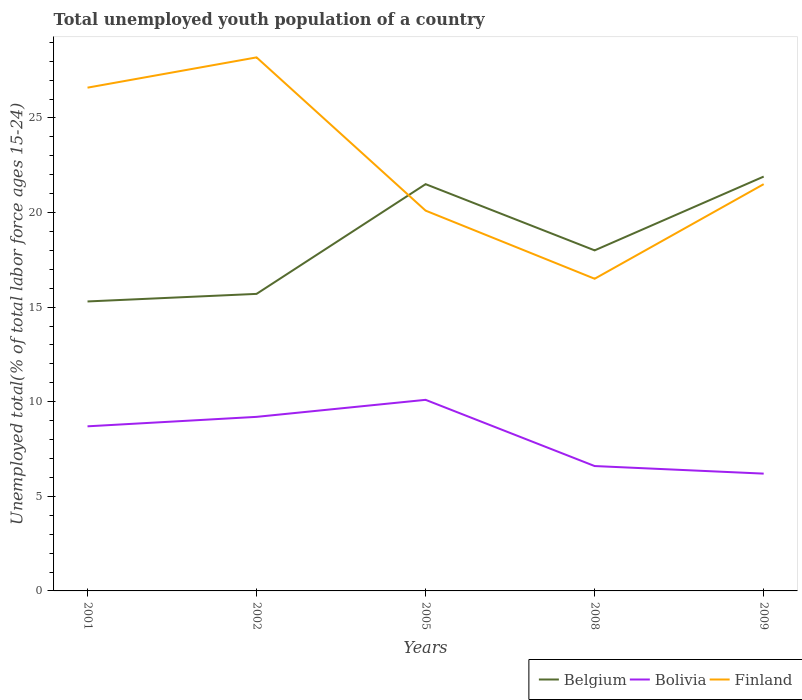How many different coloured lines are there?
Provide a succinct answer. 3. Does the line corresponding to Bolivia intersect with the line corresponding to Finland?
Your response must be concise. No. Is the number of lines equal to the number of legend labels?
Provide a succinct answer. Yes. What is the total percentage of total unemployed youth population of a country in Finland in the graph?
Your answer should be compact. -1.4. What is the difference between the highest and the second highest percentage of total unemployed youth population of a country in Belgium?
Provide a succinct answer. 6.6. What is the difference between the highest and the lowest percentage of total unemployed youth population of a country in Belgium?
Provide a short and direct response. 2. Is the percentage of total unemployed youth population of a country in Belgium strictly greater than the percentage of total unemployed youth population of a country in Finland over the years?
Your answer should be very brief. No. What is the difference between two consecutive major ticks on the Y-axis?
Keep it short and to the point. 5. How many legend labels are there?
Ensure brevity in your answer.  3. How are the legend labels stacked?
Make the answer very short. Horizontal. What is the title of the graph?
Give a very brief answer. Total unemployed youth population of a country. What is the label or title of the Y-axis?
Give a very brief answer. Unemployed total(% of total labor force ages 15-24). What is the Unemployed total(% of total labor force ages 15-24) in Belgium in 2001?
Ensure brevity in your answer.  15.3. What is the Unemployed total(% of total labor force ages 15-24) in Bolivia in 2001?
Keep it short and to the point. 8.7. What is the Unemployed total(% of total labor force ages 15-24) in Finland in 2001?
Provide a succinct answer. 26.6. What is the Unemployed total(% of total labor force ages 15-24) of Belgium in 2002?
Provide a short and direct response. 15.7. What is the Unemployed total(% of total labor force ages 15-24) of Bolivia in 2002?
Make the answer very short. 9.2. What is the Unemployed total(% of total labor force ages 15-24) of Finland in 2002?
Give a very brief answer. 28.2. What is the Unemployed total(% of total labor force ages 15-24) of Bolivia in 2005?
Ensure brevity in your answer.  10.1. What is the Unemployed total(% of total labor force ages 15-24) of Finland in 2005?
Provide a short and direct response. 20.1. What is the Unemployed total(% of total labor force ages 15-24) in Belgium in 2008?
Offer a very short reply. 18. What is the Unemployed total(% of total labor force ages 15-24) in Bolivia in 2008?
Keep it short and to the point. 6.6. What is the Unemployed total(% of total labor force ages 15-24) in Belgium in 2009?
Provide a short and direct response. 21.9. What is the Unemployed total(% of total labor force ages 15-24) in Bolivia in 2009?
Offer a terse response. 6.2. What is the Unemployed total(% of total labor force ages 15-24) of Finland in 2009?
Keep it short and to the point. 21.5. Across all years, what is the maximum Unemployed total(% of total labor force ages 15-24) of Belgium?
Offer a terse response. 21.9. Across all years, what is the maximum Unemployed total(% of total labor force ages 15-24) in Bolivia?
Your response must be concise. 10.1. Across all years, what is the maximum Unemployed total(% of total labor force ages 15-24) of Finland?
Provide a succinct answer. 28.2. Across all years, what is the minimum Unemployed total(% of total labor force ages 15-24) of Belgium?
Offer a very short reply. 15.3. Across all years, what is the minimum Unemployed total(% of total labor force ages 15-24) of Bolivia?
Provide a short and direct response. 6.2. Across all years, what is the minimum Unemployed total(% of total labor force ages 15-24) of Finland?
Your response must be concise. 16.5. What is the total Unemployed total(% of total labor force ages 15-24) in Belgium in the graph?
Your answer should be very brief. 92.4. What is the total Unemployed total(% of total labor force ages 15-24) in Bolivia in the graph?
Your response must be concise. 40.8. What is the total Unemployed total(% of total labor force ages 15-24) of Finland in the graph?
Offer a terse response. 112.9. What is the difference between the Unemployed total(% of total labor force ages 15-24) in Belgium in 2001 and that in 2002?
Keep it short and to the point. -0.4. What is the difference between the Unemployed total(% of total labor force ages 15-24) of Bolivia in 2001 and that in 2008?
Provide a succinct answer. 2.1. What is the difference between the Unemployed total(% of total labor force ages 15-24) in Finland in 2001 and that in 2008?
Your response must be concise. 10.1. What is the difference between the Unemployed total(% of total labor force ages 15-24) in Belgium in 2002 and that in 2008?
Offer a terse response. -2.3. What is the difference between the Unemployed total(% of total labor force ages 15-24) of Finland in 2002 and that in 2008?
Your answer should be compact. 11.7. What is the difference between the Unemployed total(% of total labor force ages 15-24) of Belgium in 2002 and that in 2009?
Offer a terse response. -6.2. What is the difference between the Unemployed total(% of total labor force ages 15-24) of Bolivia in 2002 and that in 2009?
Your answer should be compact. 3. What is the difference between the Unemployed total(% of total labor force ages 15-24) in Finland in 2002 and that in 2009?
Provide a succinct answer. 6.7. What is the difference between the Unemployed total(% of total labor force ages 15-24) of Belgium in 2005 and that in 2008?
Ensure brevity in your answer.  3.5. What is the difference between the Unemployed total(% of total labor force ages 15-24) in Finland in 2005 and that in 2009?
Provide a short and direct response. -1.4. What is the difference between the Unemployed total(% of total labor force ages 15-24) of Bolivia in 2008 and that in 2009?
Offer a very short reply. 0.4. What is the difference between the Unemployed total(% of total labor force ages 15-24) of Belgium in 2001 and the Unemployed total(% of total labor force ages 15-24) of Bolivia in 2002?
Provide a short and direct response. 6.1. What is the difference between the Unemployed total(% of total labor force ages 15-24) of Bolivia in 2001 and the Unemployed total(% of total labor force ages 15-24) of Finland in 2002?
Keep it short and to the point. -19.5. What is the difference between the Unemployed total(% of total labor force ages 15-24) in Belgium in 2001 and the Unemployed total(% of total labor force ages 15-24) in Bolivia in 2008?
Keep it short and to the point. 8.7. What is the difference between the Unemployed total(% of total labor force ages 15-24) in Belgium in 2001 and the Unemployed total(% of total labor force ages 15-24) in Finland in 2008?
Make the answer very short. -1.2. What is the difference between the Unemployed total(% of total labor force ages 15-24) of Bolivia in 2001 and the Unemployed total(% of total labor force ages 15-24) of Finland in 2008?
Your response must be concise. -7.8. What is the difference between the Unemployed total(% of total labor force ages 15-24) in Belgium in 2001 and the Unemployed total(% of total labor force ages 15-24) in Bolivia in 2009?
Offer a very short reply. 9.1. What is the difference between the Unemployed total(% of total labor force ages 15-24) of Belgium in 2001 and the Unemployed total(% of total labor force ages 15-24) of Finland in 2009?
Keep it short and to the point. -6.2. What is the difference between the Unemployed total(% of total labor force ages 15-24) of Bolivia in 2001 and the Unemployed total(% of total labor force ages 15-24) of Finland in 2009?
Ensure brevity in your answer.  -12.8. What is the difference between the Unemployed total(% of total labor force ages 15-24) of Bolivia in 2002 and the Unemployed total(% of total labor force ages 15-24) of Finland in 2005?
Give a very brief answer. -10.9. What is the difference between the Unemployed total(% of total labor force ages 15-24) in Belgium in 2002 and the Unemployed total(% of total labor force ages 15-24) in Finland in 2008?
Your response must be concise. -0.8. What is the difference between the Unemployed total(% of total labor force ages 15-24) of Bolivia in 2002 and the Unemployed total(% of total labor force ages 15-24) of Finland in 2008?
Keep it short and to the point. -7.3. What is the difference between the Unemployed total(% of total labor force ages 15-24) in Belgium in 2002 and the Unemployed total(% of total labor force ages 15-24) in Bolivia in 2009?
Keep it short and to the point. 9.5. What is the difference between the Unemployed total(% of total labor force ages 15-24) in Bolivia in 2002 and the Unemployed total(% of total labor force ages 15-24) in Finland in 2009?
Provide a short and direct response. -12.3. What is the difference between the Unemployed total(% of total labor force ages 15-24) of Belgium in 2005 and the Unemployed total(% of total labor force ages 15-24) of Finland in 2008?
Your answer should be very brief. 5. What is the difference between the Unemployed total(% of total labor force ages 15-24) of Bolivia in 2005 and the Unemployed total(% of total labor force ages 15-24) of Finland in 2008?
Your answer should be very brief. -6.4. What is the difference between the Unemployed total(% of total labor force ages 15-24) in Belgium in 2005 and the Unemployed total(% of total labor force ages 15-24) in Finland in 2009?
Your answer should be very brief. 0. What is the difference between the Unemployed total(% of total labor force ages 15-24) of Belgium in 2008 and the Unemployed total(% of total labor force ages 15-24) of Bolivia in 2009?
Your answer should be compact. 11.8. What is the difference between the Unemployed total(% of total labor force ages 15-24) in Bolivia in 2008 and the Unemployed total(% of total labor force ages 15-24) in Finland in 2009?
Give a very brief answer. -14.9. What is the average Unemployed total(% of total labor force ages 15-24) of Belgium per year?
Offer a very short reply. 18.48. What is the average Unemployed total(% of total labor force ages 15-24) of Bolivia per year?
Make the answer very short. 8.16. What is the average Unemployed total(% of total labor force ages 15-24) in Finland per year?
Offer a very short reply. 22.58. In the year 2001, what is the difference between the Unemployed total(% of total labor force ages 15-24) in Belgium and Unemployed total(% of total labor force ages 15-24) in Bolivia?
Offer a terse response. 6.6. In the year 2001, what is the difference between the Unemployed total(% of total labor force ages 15-24) in Belgium and Unemployed total(% of total labor force ages 15-24) in Finland?
Provide a succinct answer. -11.3. In the year 2001, what is the difference between the Unemployed total(% of total labor force ages 15-24) of Bolivia and Unemployed total(% of total labor force ages 15-24) of Finland?
Offer a terse response. -17.9. In the year 2002, what is the difference between the Unemployed total(% of total labor force ages 15-24) in Belgium and Unemployed total(% of total labor force ages 15-24) in Finland?
Keep it short and to the point. -12.5. In the year 2002, what is the difference between the Unemployed total(% of total labor force ages 15-24) of Bolivia and Unemployed total(% of total labor force ages 15-24) of Finland?
Your answer should be compact. -19. In the year 2005, what is the difference between the Unemployed total(% of total labor force ages 15-24) of Belgium and Unemployed total(% of total labor force ages 15-24) of Bolivia?
Keep it short and to the point. 11.4. In the year 2005, what is the difference between the Unemployed total(% of total labor force ages 15-24) in Belgium and Unemployed total(% of total labor force ages 15-24) in Finland?
Your answer should be compact. 1.4. In the year 2008, what is the difference between the Unemployed total(% of total labor force ages 15-24) of Belgium and Unemployed total(% of total labor force ages 15-24) of Finland?
Your answer should be very brief. 1.5. In the year 2009, what is the difference between the Unemployed total(% of total labor force ages 15-24) in Belgium and Unemployed total(% of total labor force ages 15-24) in Bolivia?
Make the answer very short. 15.7. In the year 2009, what is the difference between the Unemployed total(% of total labor force ages 15-24) of Belgium and Unemployed total(% of total labor force ages 15-24) of Finland?
Keep it short and to the point. 0.4. In the year 2009, what is the difference between the Unemployed total(% of total labor force ages 15-24) of Bolivia and Unemployed total(% of total labor force ages 15-24) of Finland?
Provide a succinct answer. -15.3. What is the ratio of the Unemployed total(% of total labor force ages 15-24) of Belgium in 2001 to that in 2002?
Keep it short and to the point. 0.97. What is the ratio of the Unemployed total(% of total labor force ages 15-24) of Bolivia in 2001 to that in 2002?
Your response must be concise. 0.95. What is the ratio of the Unemployed total(% of total labor force ages 15-24) in Finland in 2001 to that in 2002?
Provide a succinct answer. 0.94. What is the ratio of the Unemployed total(% of total labor force ages 15-24) of Belgium in 2001 to that in 2005?
Keep it short and to the point. 0.71. What is the ratio of the Unemployed total(% of total labor force ages 15-24) in Bolivia in 2001 to that in 2005?
Provide a short and direct response. 0.86. What is the ratio of the Unemployed total(% of total labor force ages 15-24) of Finland in 2001 to that in 2005?
Offer a terse response. 1.32. What is the ratio of the Unemployed total(% of total labor force ages 15-24) of Belgium in 2001 to that in 2008?
Your response must be concise. 0.85. What is the ratio of the Unemployed total(% of total labor force ages 15-24) of Bolivia in 2001 to that in 2008?
Offer a terse response. 1.32. What is the ratio of the Unemployed total(% of total labor force ages 15-24) of Finland in 2001 to that in 2008?
Make the answer very short. 1.61. What is the ratio of the Unemployed total(% of total labor force ages 15-24) in Belgium in 2001 to that in 2009?
Provide a succinct answer. 0.7. What is the ratio of the Unemployed total(% of total labor force ages 15-24) in Bolivia in 2001 to that in 2009?
Your response must be concise. 1.4. What is the ratio of the Unemployed total(% of total labor force ages 15-24) in Finland in 2001 to that in 2009?
Give a very brief answer. 1.24. What is the ratio of the Unemployed total(% of total labor force ages 15-24) of Belgium in 2002 to that in 2005?
Your answer should be very brief. 0.73. What is the ratio of the Unemployed total(% of total labor force ages 15-24) in Bolivia in 2002 to that in 2005?
Provide a short and direct response. 0.91. What is the ratio of the Unemployed total(% of total labor force ages 15-24) in Finland in 2002 to that in 2005?
Your answer should be very brief. 1.4. What is the ratio of the Unemployed total(% of total labor force ages 15-24) of Belgium in 2002 to that in 2008?
Keep it short and to the point. 0.87. What is the ratio of the Unemployed total(% of total labor force ages 15-24) of Bolivia in 2002 to that in 2008?
Provide a succinct answer. 1.39. What is the ratio of the Unemployed total(% of total labor force ages 15-24) in Finland in 2002 to that in 2008?
Provide a short and direct response. 1.71. What is the ratio of the Unemployed total(% of total labor force ages 15-24) in Belgium in 2002 to that in 2009?
Your answer should be very brief. 0.72. What is the ratio of the Unemployed total(% of total labor force ages 15-24) of Bolivia in 2002 to that in 2009?
Your response must be concise. 1.48. What is the ratio of the Unemployed total(% of total labor force ages 15-24) in Finland in 2002 to that in 2009?
Give a very brief answer. 1.31. What is the ratio of the Unemployed total(% of total labor force ages 15-24) of Belgium in 2005 to that in 2008?
Your answer should be compact. 1.19. What is the ratio of the Unemployed total(% of total labor force ages 15-24) in Bolivia in 2005 to that in 2008?
Ensure brevity in your answer.  1.53. What is the ratio of the Unemployed total(% of total labor force ages 15-24) in Finland in 2005 to that in 2008?
Your response must be concise. 1.22. What is the ratio of the Unemployed total(% of total labor force ages 15-24) of Belgium in 2005 to that in 2009?
Provide a succinct answer. 0.98. What is the ratio of the Unemployed total(% of total labor force ages 15-24) in Bolivia in 2005 to that in 2009?
Your answer should be compact. 1.63. What is the ratio of the Unemployed total(% of total labor force ages 15-24) in Finland in 2005 to that in 2009?
Keep it short and to the point. 0.93. What is the ratio of the Unemployed total(% of total labor force ages 15-24) in Belgium in 2008 to that in 2009?
Your answer should be compact. 0.82. What is the ratio of the Unemployed total(% of total labor force ages 15-24) in Bolivia in 2008 to that in 2009?
Your answer should be very brief. 1.06. What is the ratio of the Unemployed total(% of total labor force ages 15-24) of Finland in 2008 to that in 2009?
Provide a succinct answer. 0.77. What is the difference between the highest and the second highest Unemployed total(% of total labor force ages 15-24) of Bolivia?
Provide a short and direct response. 0.9. What is the difference between the highest and the lowest Unemployed total(% of total labor force ages 15-24) of Belgium?
Provide a succinct answer. 6.6. What is the difference between the highest and the lowest Unemployed total(% of total labor force ages 15-24) in Finland?
Your answer should be compact. 11.7. 